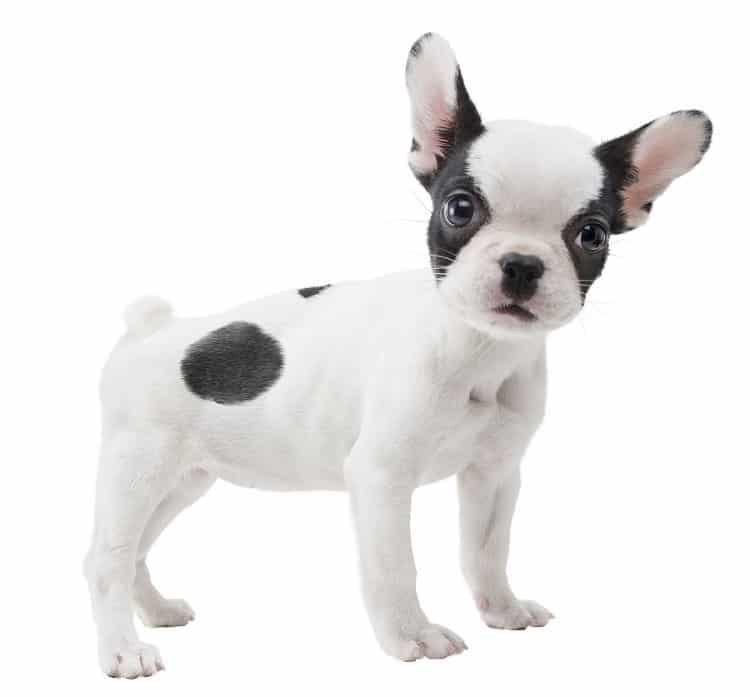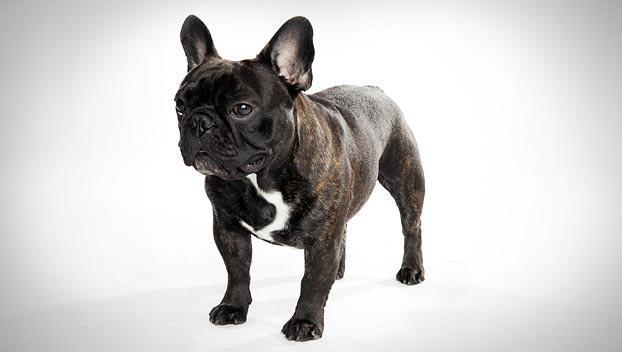The first image is the image on the left, the second image is the image on the right. Analyze the images presented: Is the assertion "In one of the images there is a single puppy lying on the floor." valid? Answer yes or no. No. 